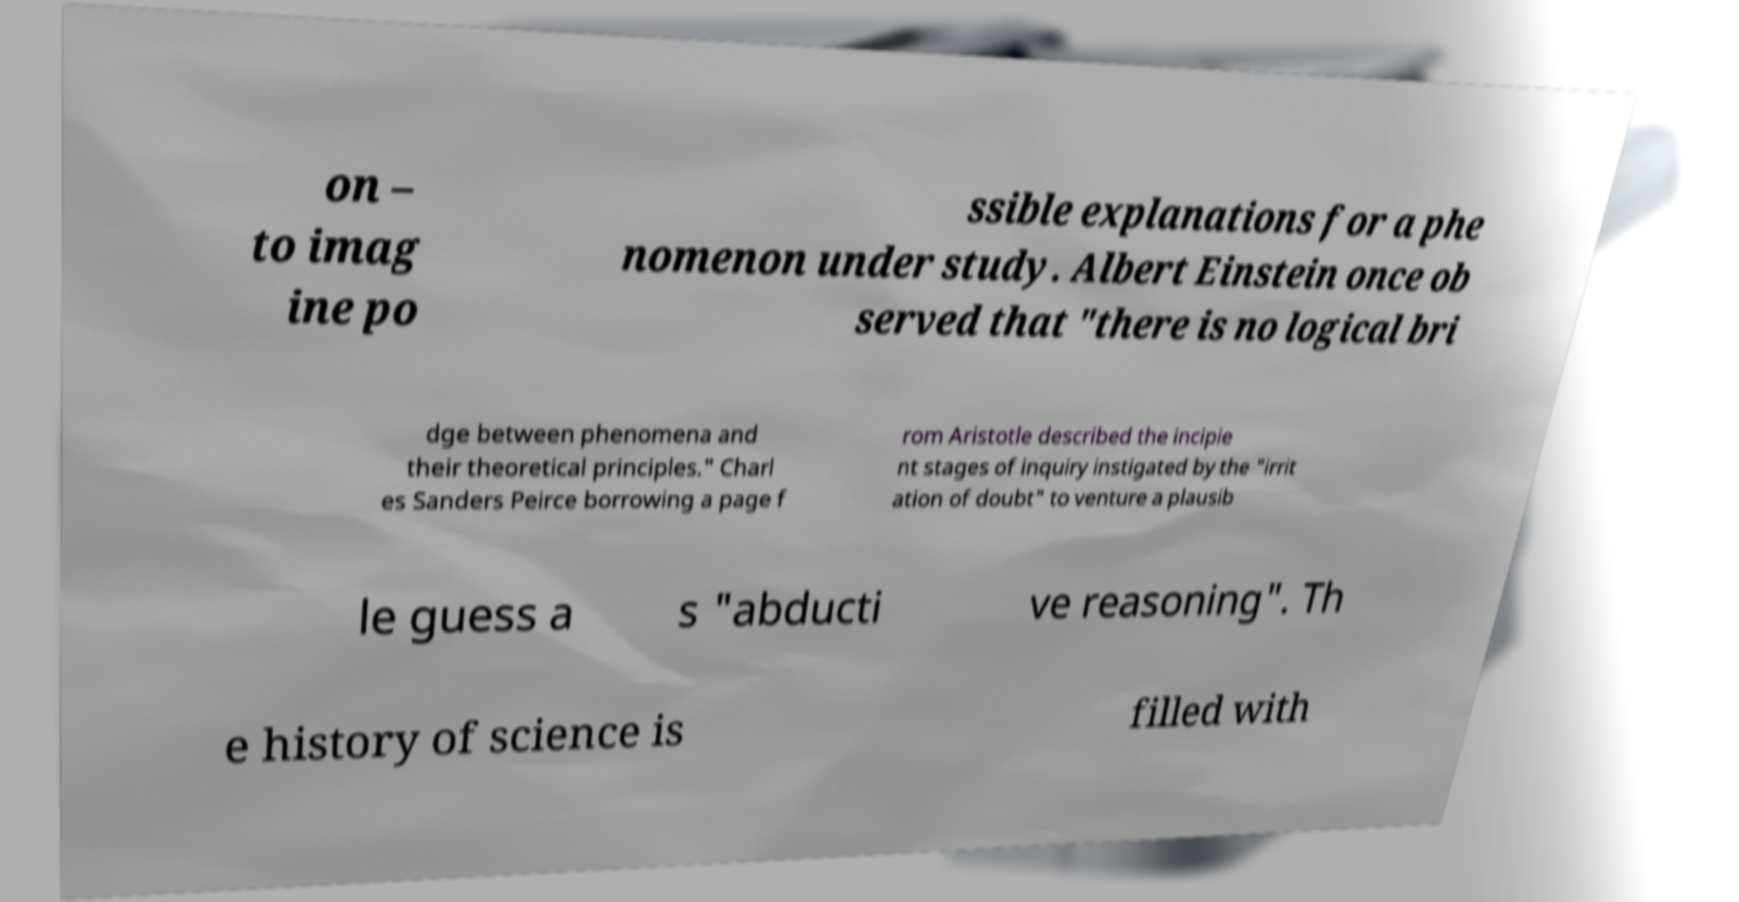For documentation purposes, I need the text within this image transcribed. Could you provide that? on – to imag ine po ssible explanations for a phe nomenon under study. Albert Einstein once ob served that "there is no logical bri dge between phenomena and their theoretical principles." Charl es Sanders Peirce borrowing a page f rom Aristotle described the incipie nt stages of inquiry instigated by the "irrit ation of doubt" to venture a plausib le guess a s "abducti ve reasoning". Th e history of science is filled with 